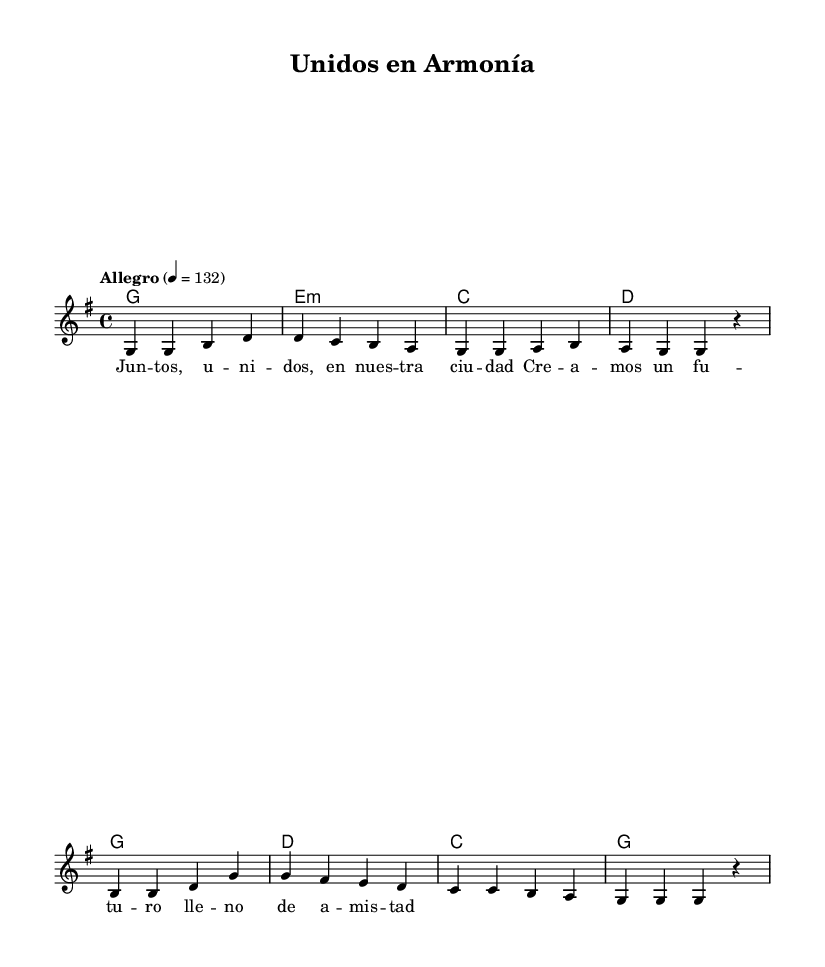What is the key signature of this music? The key signature is G major, which has one sharp (F#). This can be identified by looking for the sharp symbols in the key signature at the beginning of the staff.
Answer: G major What is the time signature of this music? The time signature is 4/4. This is indicated at the beginning of the staff next to the key signature, showing that there are four beats in a measure and that the quarter note gets one beat.
Answer: 4/4 What is the tempo marking of the song? The tempo marking is "Allegro," which indicates a fast and lively pace for the piece. The number "132" refers to the beats per minute, further clarifying the speed.
Answer: Allegro How many measures are in the score? There are eight measures in total. By counting the vertical bar lines that indicate the end of each measure in the melody, we can see that there are eight distinct groups.
Answer: 8 What is the main theme of the lyrics? The main theme of the lyrics focuses on community and unity, as shown by the words "Unidos," and "nuestra ciudad," which translate to "United" and "our city," respectively. This conveys a message of coming together.
Answer: Community What chords are used in the first measure? The chord used in the first measure is G. Analyzing the specific placement of the chord symbols above the melody notes will reveal the chord played at that time.
Answer: G What is the overall mood of the song likely to be? The overall mood of the song is upbeat and celebratory. This is inferred from the tempo marking "Allegro" and the use of major chords, which generally convey happiness and positivity.
Answer: Upbeat 